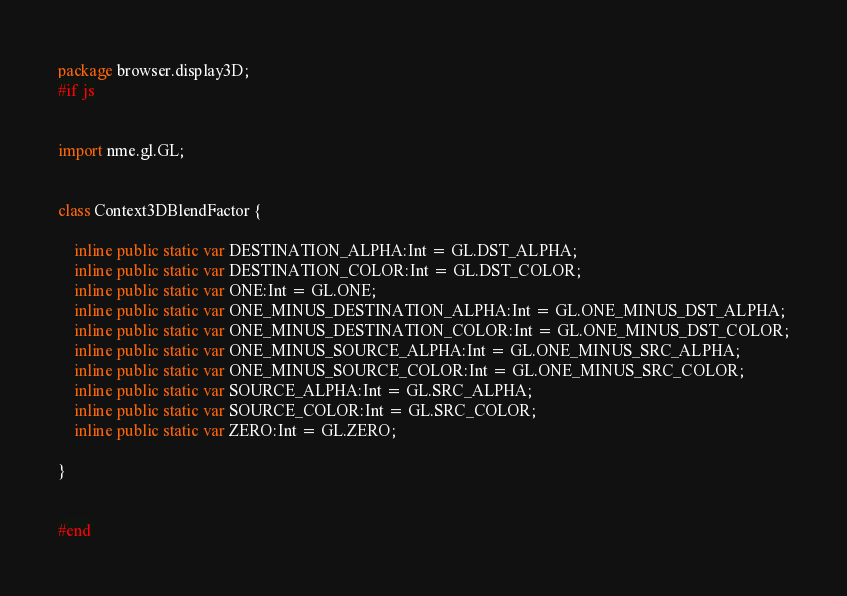<code> <loc_0><loc_0><loc_500><loc_500><_Haxe_>package browser.display3D;
#if js


import nme.gl.GL;


class Context3DBlendFactor {
	
	inline public static var DESTINATION_ALPHA:Int = GL.DST_ALPHA;
	inline public static var DESTINATION_COLOR:Int = GL.DST_COLOR;
	inline public static var ONE:Int = GL.ONE;
	inline public static var ONE_MINUS_DESTINATION_ALPHA:Int = GL.ONE_MINUS_DST_ALPHA;
	inline public static var ONE_MINUS_DESTINATION_COLOR:Int = GL.ONE_MINUS_DST_COLOR;
	inline public static var ONE_MINUS_SOURCE_ALPHA:Int = GL.ONE_MINUS_SRC_ALPHA;
	inline public static var ONE_MINUS_SOURCE_COLOR:Int = GL.ONE_MINUS_SRC_COLOR;
	inline public static var SOURCE_ALPHA:Int = GL.SRC_ALPHA;
	inline public static var SOURCE_COLOR:Int = GL.SRC_COLOR;
	inline public static var ZERO:Int = GL.ZERO;
	
}


#end</code> 